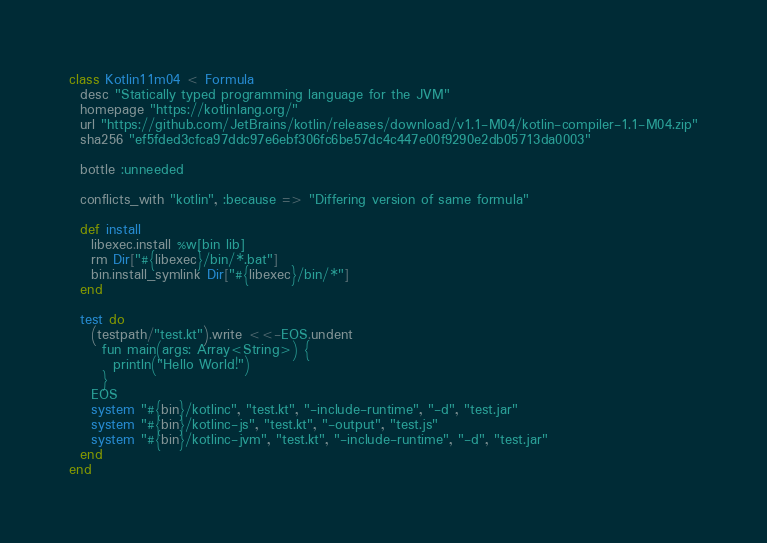Convert code to text. <code><loc_0><loc_0><loc_500><loc_500><_Ruby_>class Kotlin11m04 < Formula
  desc "Statically typed programming language for the JVM"
  homepage "https://kotlinlang.org/"
  url "https://github.com/JetBrains/kotlin/releases/download/v1.1-M04/kotlin-compiler-1.1-M04.zip"
  sha256 "ef5fded3cfca97ddc97e6ebf306fc6be57dc4c447e00f9290e2db05713da0003"

  bottle :unneeded

  conflicts_with "kotlin", :because => "Differing version of same formula"

  def install
    libexec.install %w[bin lib]
    rm Dir["#{libexec}/bin/*.bat"]
    bin.install_symlink Dir["#{libexec}/bin/*"]
  end

  test do
    (testpath/"test.kt").write <<-EOS.undent
      fun main(args: Array<String>) {
        println("Hello World!")
      }
    EOS
    system "#{bin}/kotlinc", "test.kt", "-include-runtime", "-d", "test.jar"
    system "#{bin}/kotlinc-js", "test.kt", "-output", "test.js"
    system "#{bin}/kotlinc-jvm", "test.kt", "-include-runtime", "-d", "test.jar"
  end
end
</code> 